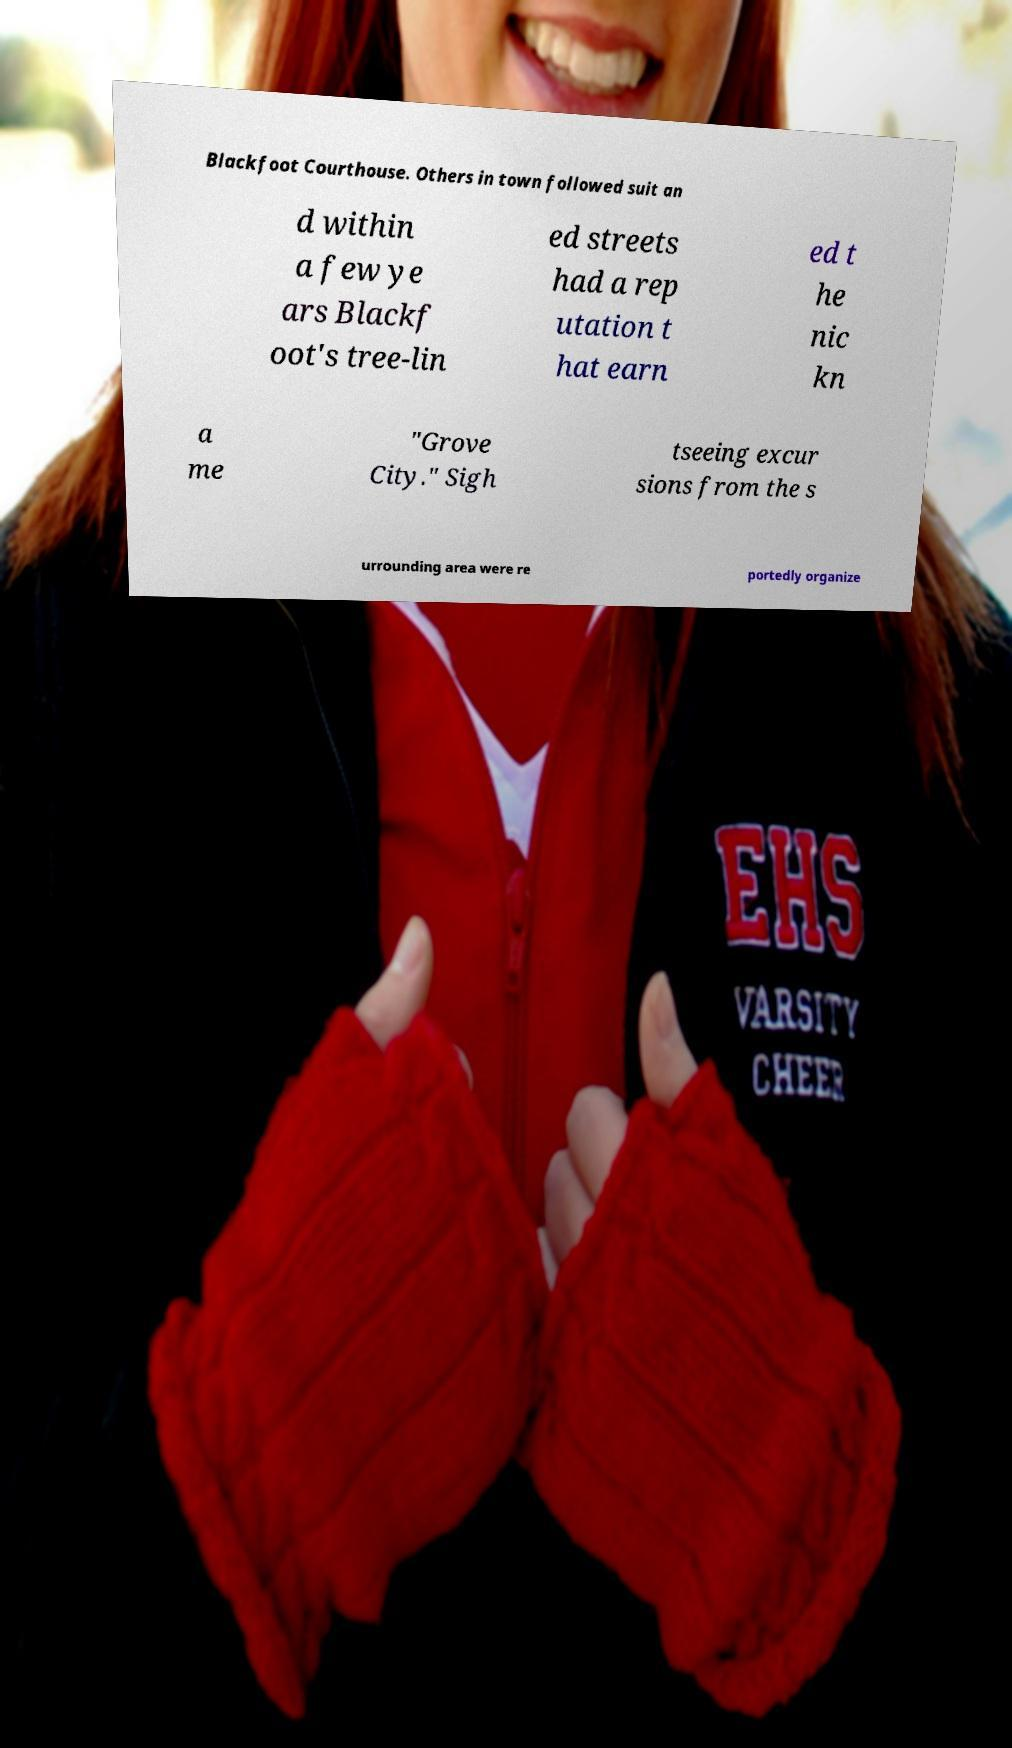There's text embedded in this image that I need extracted. Can you transcribe it verbatim? Blackfoot Courthouse. Others in town followed suit an d within a few ye ars Blackf oot's tree-lin ed streets had a rep utation t hat earn ed t he nic kn a me "Grove City." Sigh tseeing excur sions from the s urrounding area were re portedly organize 